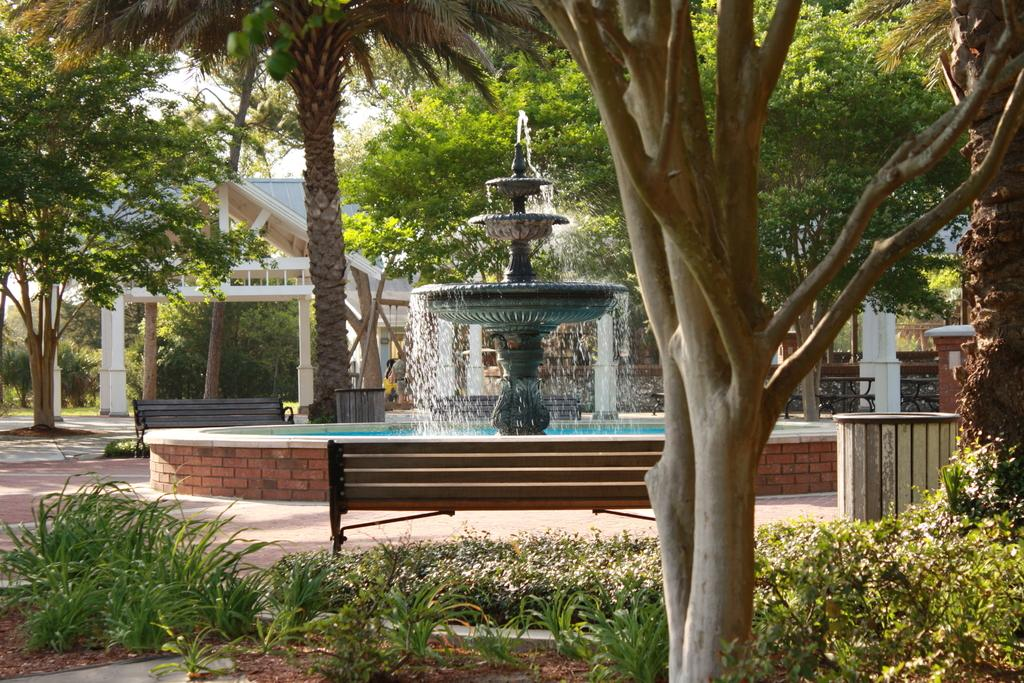What type of vegetation can be seen in the image? There are trees in the image. What type of structure is present in the image? There is an open shed in the image. What can be found on the ground in the image? There are plans in the image. What type of seating is available in the image? There are benches in the image. What feature is present for providing water in the image? There is a water fountain in the image. What are the bins used for in the image? The bins are used for waste disposal in the image. What type of patch is visible on the throat of the person in the image? There is no person present in the image, so there is no throat or patch to be observed. How does the image suggest that the environment might change in the future? The image does not provide any information about future changes in the environment. 